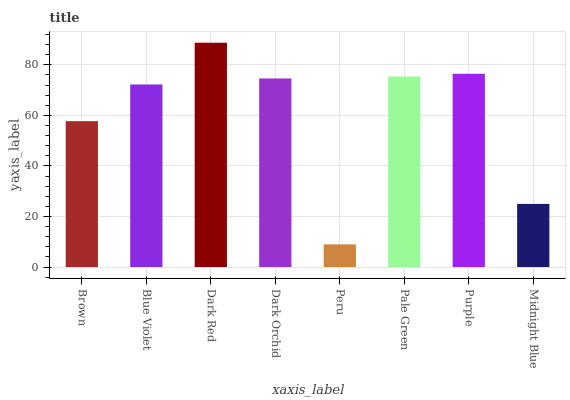Is Peru the minimum?
Answer yes or no. Yes. Is Dark Red the maximum?
Answer yes or no. Yes. Is Blue Violet the minimum?
Answer yes or no. No. Is Blue Violet the maximum?
Answer yes or no. No. Is Blue Violet greater than Brown?
Answer yes or no. Yes. Is Brown less than Blue Violet?
Answer yes or no. Yes. Is Brown greater than Blue Violet?
Answer yes or no. No. Is Blue Violet less than Brown?
Answer yes or no. No. Is Dark Orchid the high median?
Answer yes or no. Yes. Is Blue Violet the low median?
Answer yes or no. Yes. Is Midnight Blue the high median?
Answer yes or no. No. Is Midnight Blue the low median?
Answer yes or no. No. 